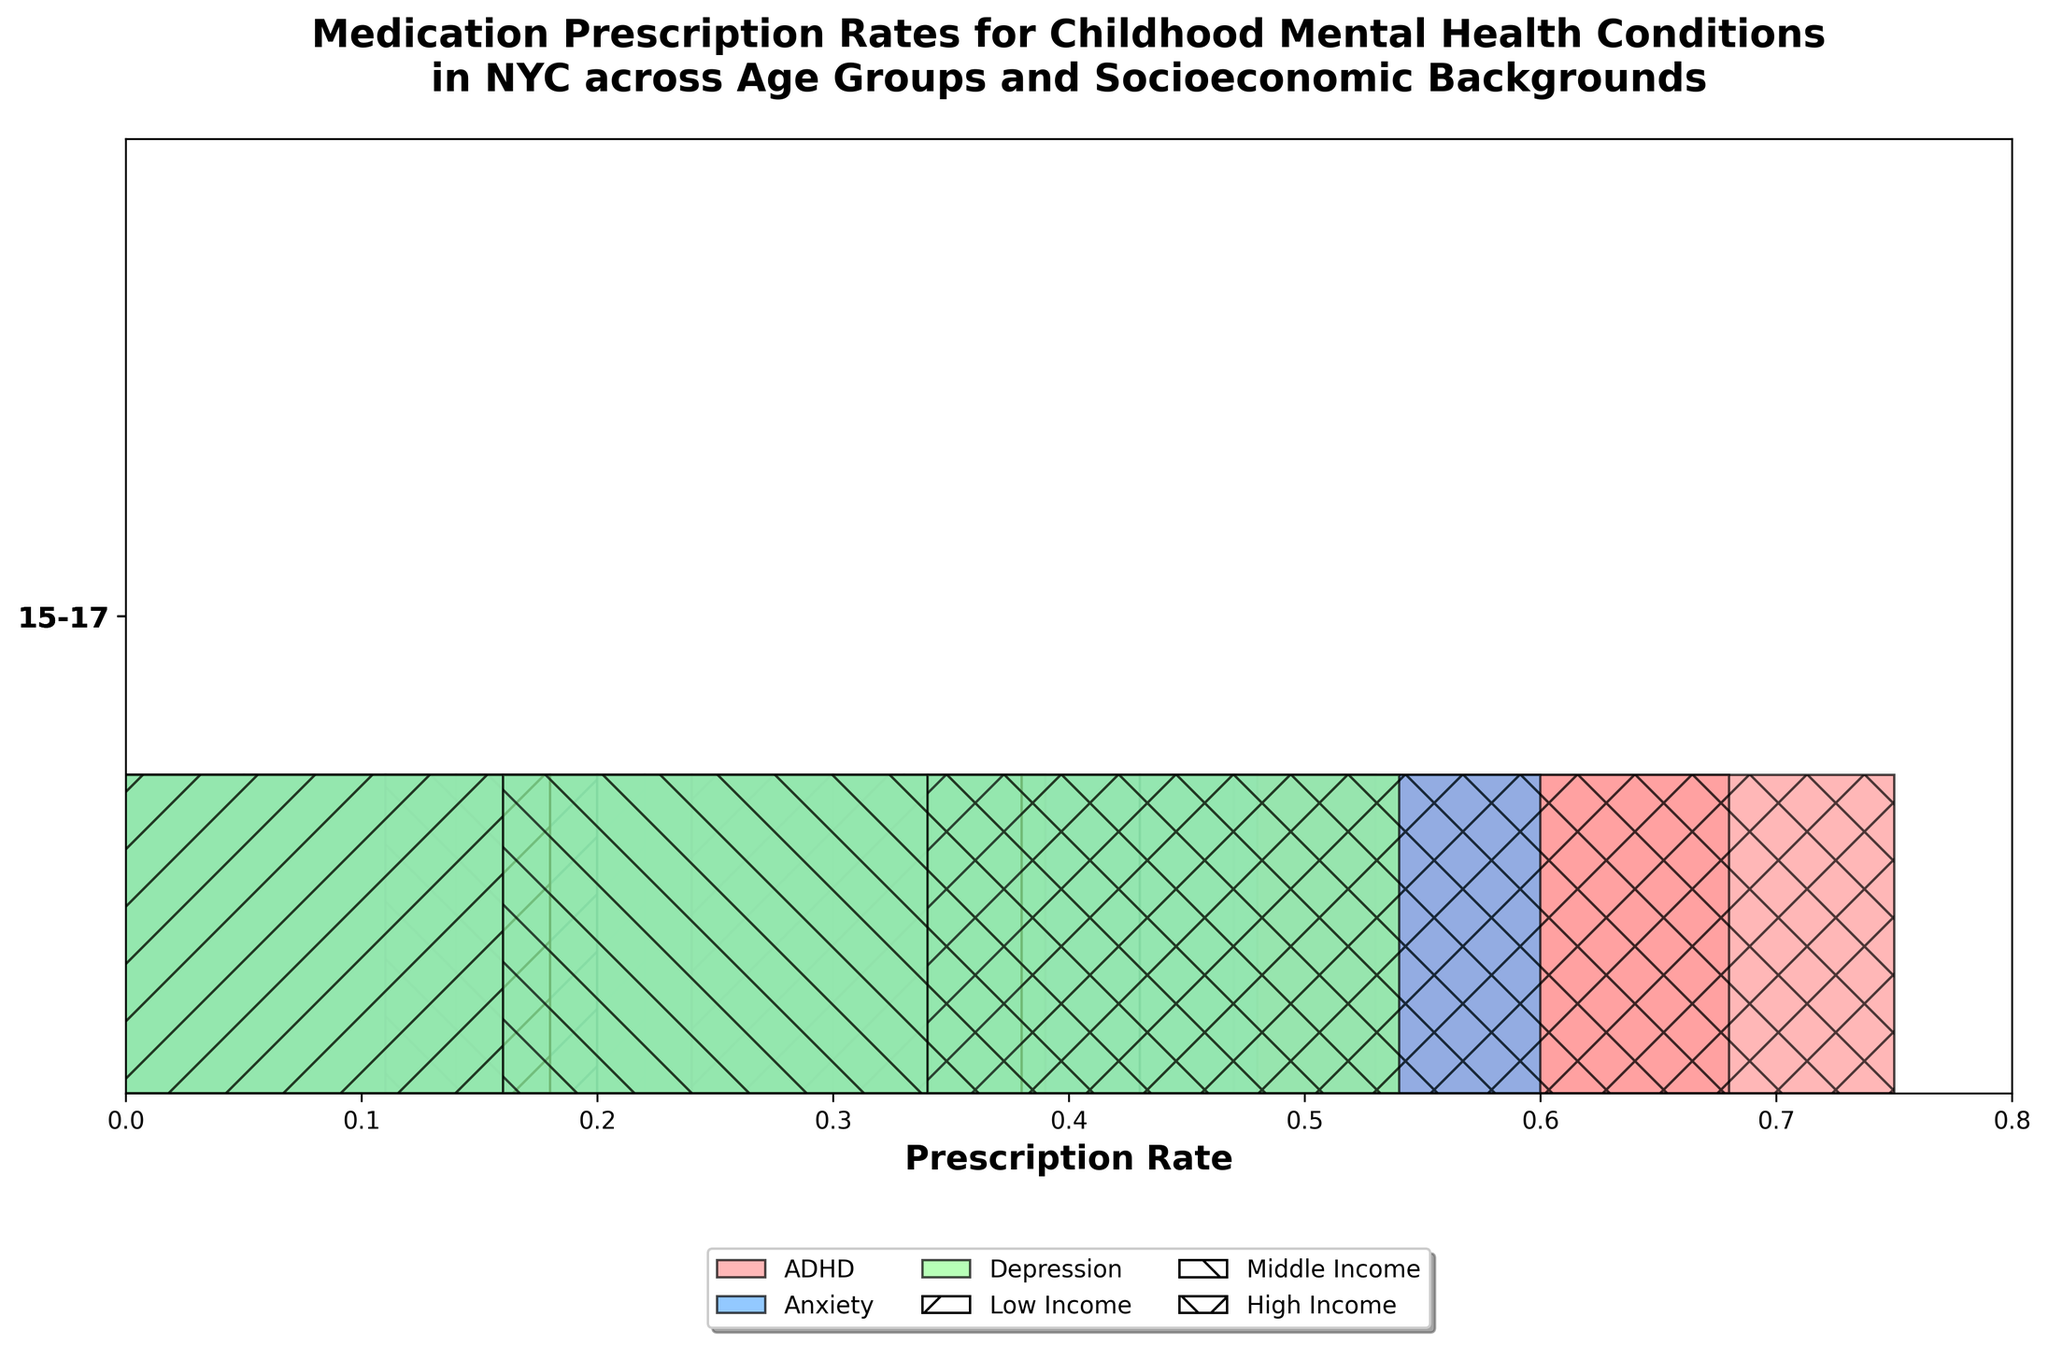What is the title of the figure? The title is visible at the top of the figure and provides a summary of what the figure is about.
Answer: Medication Prescription Rates for Childhood Mental Health Conditions in NYC across Age Groups and Socioeconomic Backgrounds Which age group has the highest prescription rate for ADHD among high-income children? To find the highest prescription rate for ADHD among high-income children, look for the largest rectangle with "ADHD" color in the "High Income" section across age groups.
Answer: 10-14 How does the prescription rate for anxiety compare between low-income children aged 5-9 and 15-17? Look at the size of the rectangles for "Anxiety" color in the "Low Income" section for 5-9 and 15-17 age groups and compare their lengths.
Answer: The rate is higher for children aged 15-17 What is the range of prescription rates for depression across all age groups in high-income backgrounds? Check the lengths of rectangles for "Depression" color in the "High Income" section for all age groups and find the maximum and minimum rates.
Answer: 0.07 - 0.20 Which socioeconomic background has the lowest prescription rate for ADHD in the 5-9 age group? Compare the lengths of rectangles for "ADHD" color in the "5-9" age group across all socioeconomic backgrounds to find the smallest one.
Answer: Low Income Which condition shows the most consistent prescription rate increase across age groups for middle-income children? Analyze the rectangles for "Middle Income" children for each condition across all age groups. The condition with the most consistently increasing rectangle sizes is the answer.
Answer: Anxiety What is the total prescription rate for ADHD in the 10-14 age group across all socioeconomic backgrounds? Sum up the lengths of the "ADHD" rectangles in the "10-14" age group across all socioeconomic backgrounds.
Answer: 0.22 + 0.25 + 0.28 = 0.75 How does the prescription rate for depression among middle-income children aged 5-9 compare to their ADHD rate in the same age group? Compare the sizes of the rectangles representing "Depression" and "ADHD" for middle-income children in the "5-9" age group.
Answer: ADHD rate is higher by 0.12 Which age group has the smallest overall prescription rate for mental health conditions among low-income children? Assess the total length of all rectangles combined for "Low Income" children in each age group. The group with the shortest total length has the smallest rate.
Answer: 5-9 